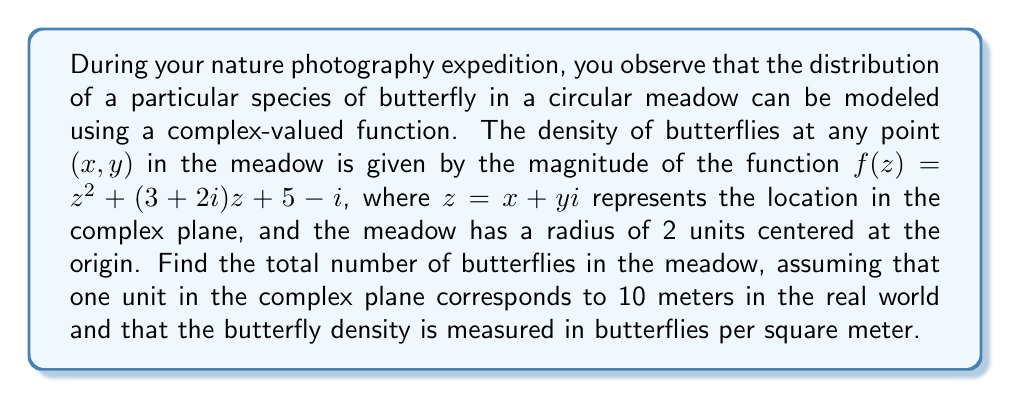Solve this math problem. To solve this problem, we'll follow these steps:

1) The density of butterflies is given by $|f(z)|$ where $f(z) = z^2 + (3+2i)z + 5-i$.

2) To find the total number of butterflies, we need to integrate this density over the area of the meadow. In complex analysis, this is done using a double integral:

   $$N = \iint_{|z|\leq 2} |f(z)| \, dA$$

   where $dA = dx dy$ is the area element.

3) This integral is challenging to compute directly. However, we can use a powerful theorem from complex analysis called the Mean Value Property for harmonic functions. The function $|f(z)|^2$ is harmonic, so its average value over a circle equals its value at the center of the circle.

4) Therefore, the average value of $|f(z)|$ over the circle equals the square root of $|f(0)|$:

   $$\frac{1}{\pi R^2} \iint_{|z|\leq R} |f(z)| \, dA = \sqrt{|f(0)|}$$

5) We can calculate $f(0)$:
   
   $f(0) = 0^2 + (3+2i)0 + 5-i = 5-i$

6) Therefore, $|f(0)| = \sqrt{5^2 + (-1)^2} = \sqrt{26}$

7) The average value of $|f(z)|$ over the circle is thus $\sqrt{\sqrt{26}}$.

8) To get the total number of butterflies, we multiply this average value by the area of the meadow:

   $$N = \pi R^2 \cdot \sqrt{\sqrt{26}}$$

9) The radius of the meadow is 2 units in the complex plane, which corresponds to 20 meters in the real world. Therefore, $R = 20$ meters.

10) Substituting this in:

    $$N = \pi \cdot 20^2 \cdot \sqrt{\sqrt{26}} \approx 2862.83$$

11) Since we can't have a fractional number of butterflies, we round to the nearest whole number.
Answer: The total number of butterflies in the meadow is approximately 2863. 